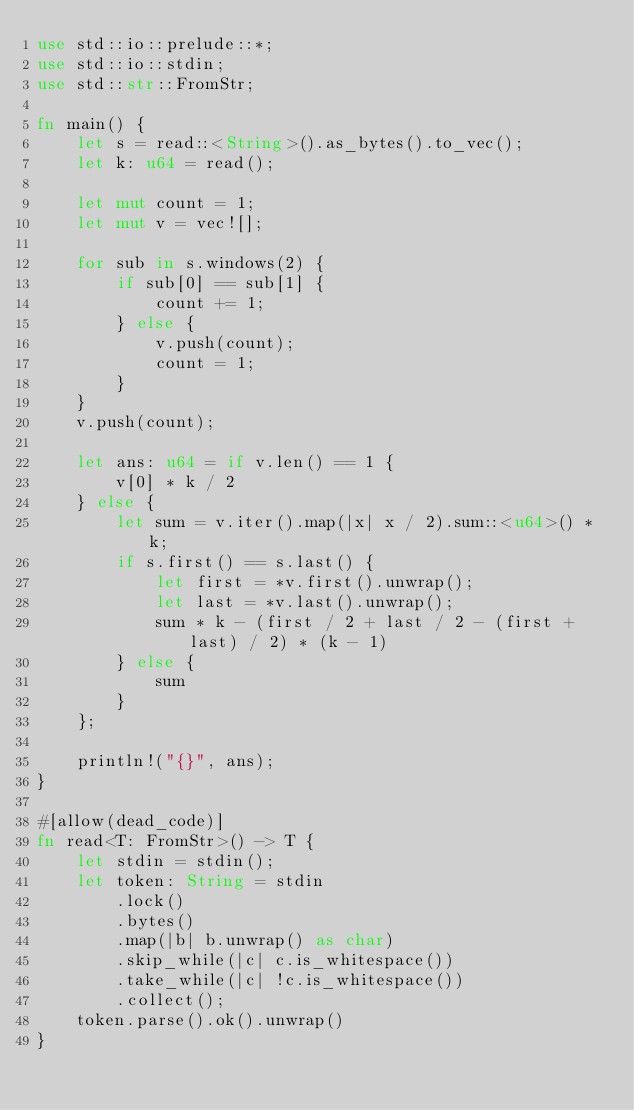Convert code to text. <code><loc_0><loc_0><loc_500><loc_500><_Rust_>use std::io::prelude::*;
use std::io::stdin;
use std::str::FromStr;

fn main() {
    let s = read::<String>().as_bytes().to_vec();
    let k: u64 = read();

    let mut count = 1;
    let mut v = vec![];

    for sub in s.windows(2) {
        if sub[0] == sub[1] {
            count += 1;
        } else {
            v.push(count);
            count = 1;
        }
    }
    v.push(count);

    let ans: u64 = if v.len() == 1 {
        v[0] * k / 2
    } else {
        let sum = v.iter().map(|x| x / 2).sum::<u64>() * k;
        if s.first() == s.last() {
            let first = *v.first().unwrap();
            let last = *v.last().unwrap();
            sum * k - (first / 2 + last / 2 - (first + last) / 2) * (k - 1)
        } else {
            sum
        }
    };

    println!("{}", ans);
}

#[allow(dead_code)]
fn read<T: FromStr>() -> T {
    let stdin = stdin();
    let token: String = stdin
        .lock()
        .bytes()
        .map(|b| b.unwrap() as char)
        .skip_while(|c| c.is_whitespace())
        .take_while(|c| !c.is_whitespace())
        .collect();
    token.parse().ok().unwrap()
}
</code> 